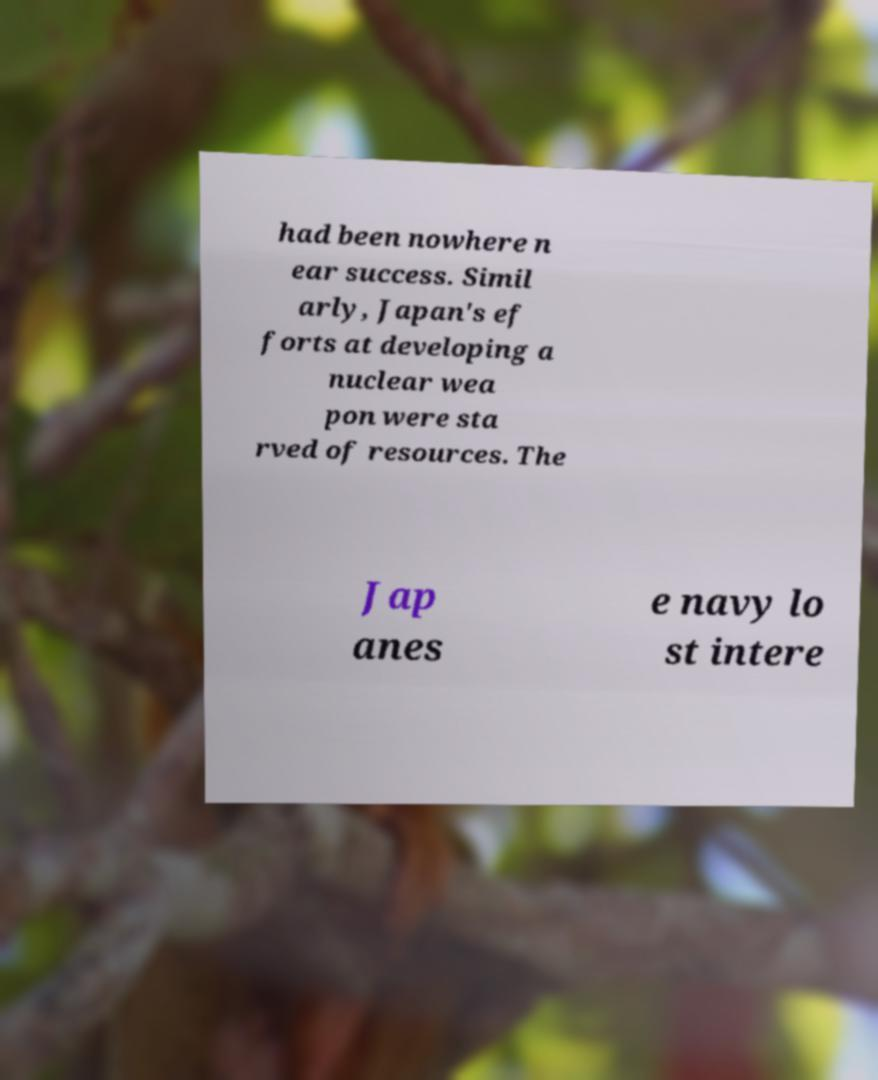For documentation purposes, I need the text within this image transcribed. Could you provide that? had been nowhere n ear success. Simil arly, Japan's ef forts at developing a nuclear wea pon were sta rved of resources. The Jap anes e navy lo st intere 